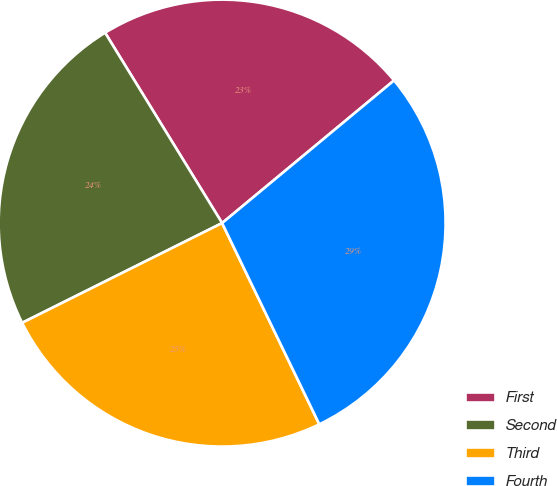Convert chart. <chart><loc_0><loc_0><loc_500><loc_500><pie_chart><fcel>First<fcel>Second<fcel>Third<fcel>Fourth<nl><fcel>22.75%<fcel>23.59%<fcel>24.8%<fcel>28.86%<nl></chart> 